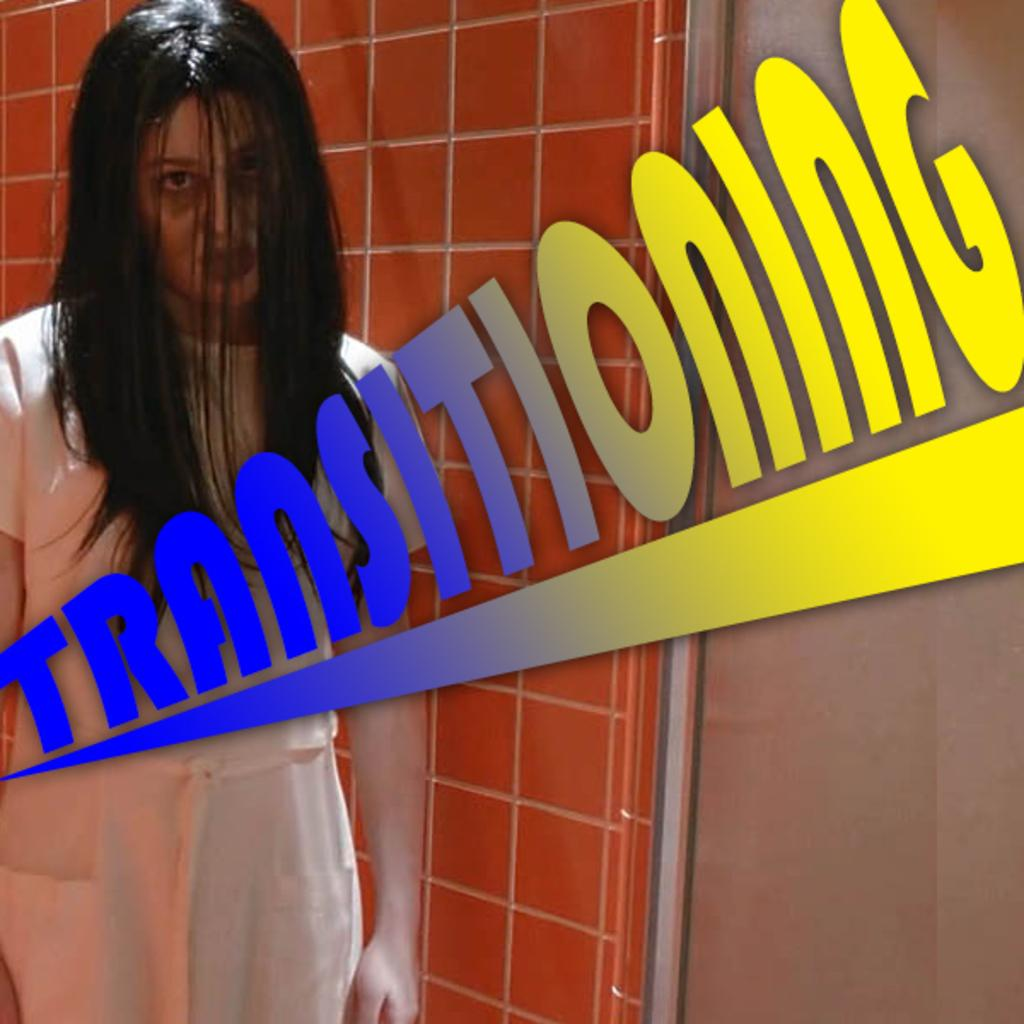<image>
Describe the image concisely. A woman stands in the shower next to a graphic that says transitioning. 